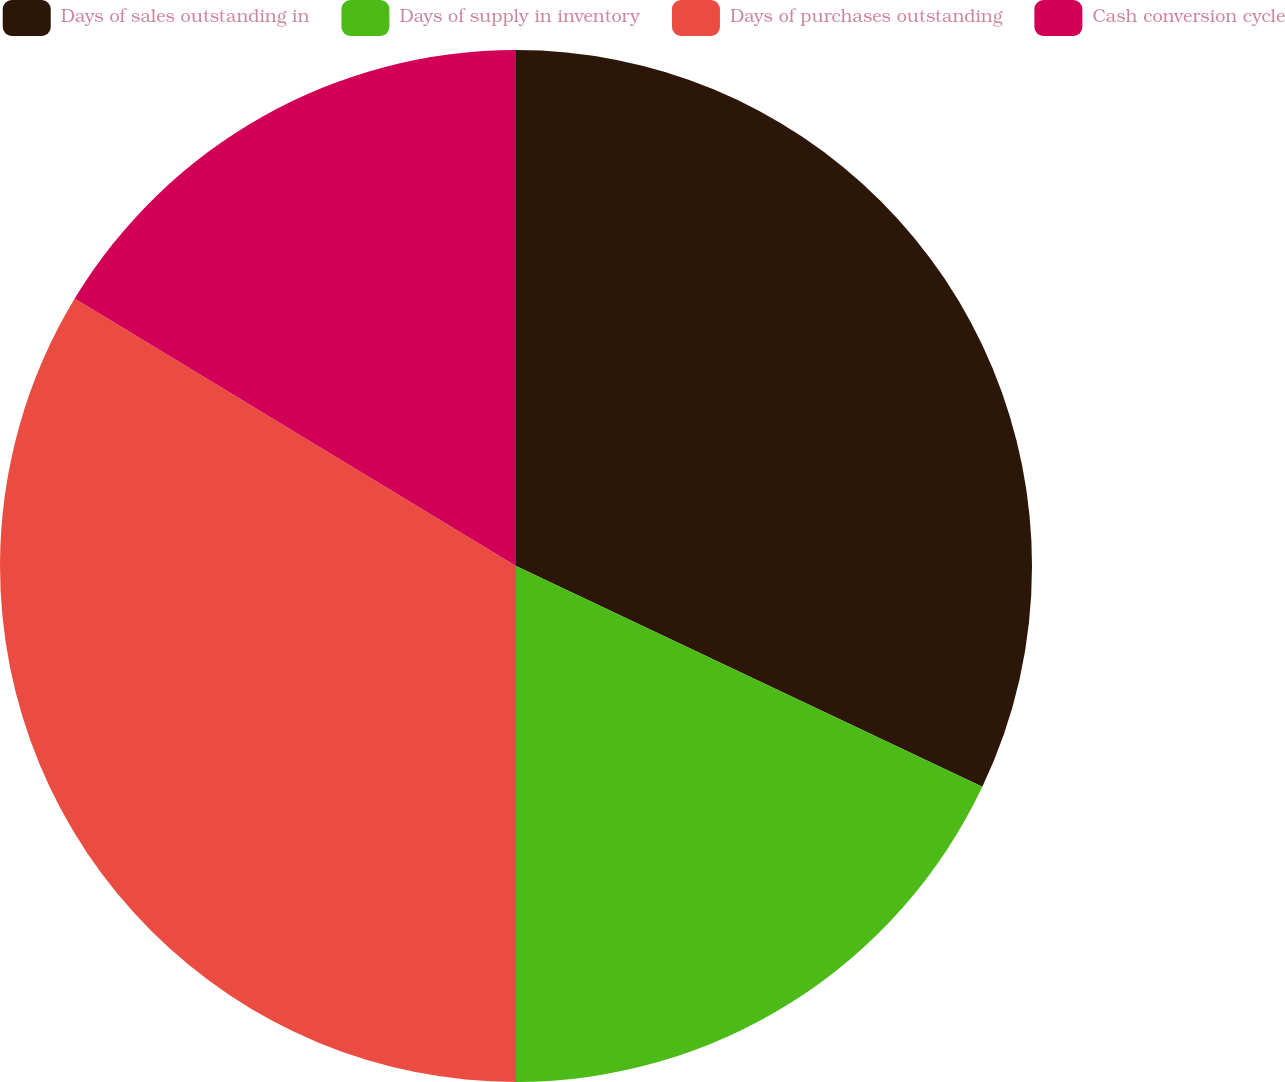Convert chart. <chart><loc_0><loc_0><loc_500><loc_500><pie_chart><fcel>Days of sales outstanding in<fcel>Days of supply in inventory<fcel>Days of purchases outstanding<fcel>Cash conversion cycle<nl><fcel>32.04%<fcel>17.96%<fcel>33.67%<fcel>16.33%<nl></chart> 